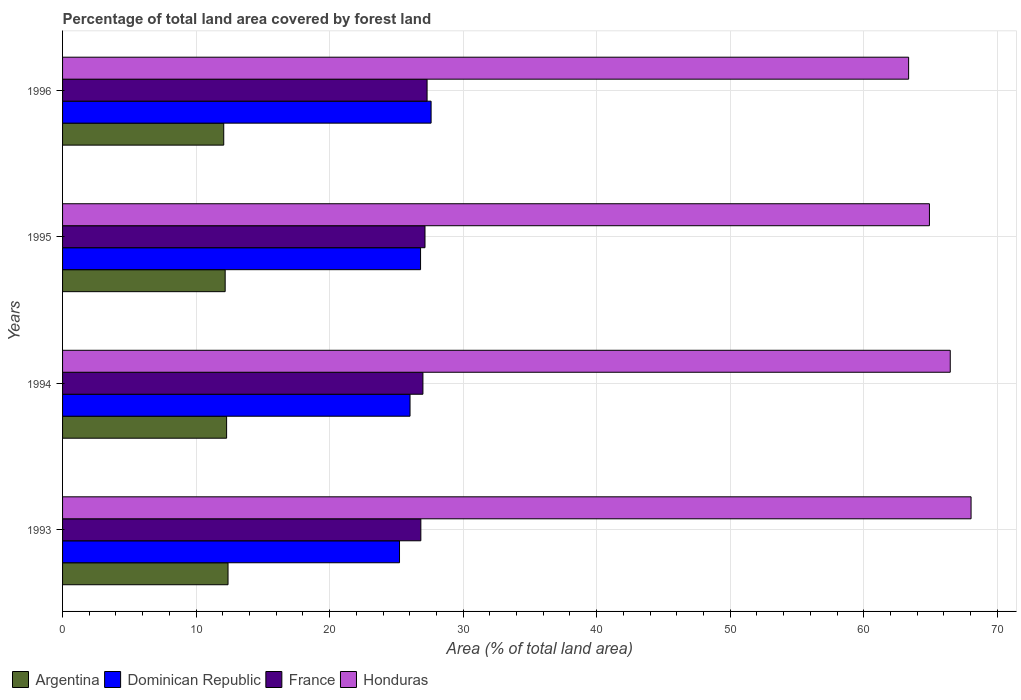How many different coloured bars are there?
Provide a succinct answer. 4. How many groups of bars are there?
Your answer should be very brief. 4. In how many cases, is the number of bars for a given year not equal to the number of legend labels?
Provide a succinct answer. 0. What is the percentage of forest land in Dominican Republic in 1994?
Offer a terse response. 26.02. Across all years, what is the maximum percentage of forest land in Dominican Republic?
Ensure brevity in your answer.  27.6. Across all years, what is the minimum percentage of forest land in Dominican Republic?
Offer a terse response. 25.23. In which year was the percentage of forest land in Honduras maximum?
Your answer should be compact. 1993. What is the total percentage of forest land in Honduras in the graph?
Provide a succinct answer. 262.8. What is the difference between the percentage of forest land in France in 1994 and that in 1996?
Offer a terse response. -0.31. What is the difference between the percentage of forest land in France in 1994 and the percentage of forest land in Honduras in 1995?
Provide a succinct answer. -37.93. What is the average percentage of forest land in Honduras per year?
Offer a terse response. 65.7. In the year 1994, what is the difference between the percentage of forest land in Dominican Republic and percentage of forest land in France?
Provide a succinct answer. -0.96. In how many years, is the percentage of forest land in Argentina greater than 10 %?
Ensure brevity in your answer.  4. What is the ratio of the percentage of forest land in Honduras in 1994 to that in 1996?
Your answer should be compact. 1.05. Is the percentage of forest land in France in 1995 less than that in 1996?
Offer a very short reply. Yes. What is the difference between the highest and the second highest percentage of forest land in Argentina?
Give a very brief answer. 0.11. What is the difference between the highest and the lowest percentage of forest land in Argentina?
Ensure brevity in your answer.  0.32. In how many years, is the percentage of forest land in Honduras greater than the average percentage of forest land in Honduras taken over all years?
Your answer should be very brief. 2. Is the sum of the percentage of forest land in Dominican Republic in 1994 and 1995 greater than the maximum percentage of forest land in France across all years?
Offer a very short reply. Yes. What does the 3rd bar from the top in 1994 represents?
Ensure brevity in your answer.  Dominican Republic. What does the 1st bar from the bottom in 1996 represents?
Make the answer very short. Argentina. How many years are there in the graph?
Ensure brevity in your answer.  4. What is the difference between two consecutive major ticks on the X-axis?
Make the answer very short. 10. Are the values on the major ticks of X-axis written in scientific E-notation?
Provide a succinct answer. No. Does the graph contain any zero values?
Give a very brief answer. No. Does the graph contain grids?
Offer a very short reply. Yes. Where does the legend appear in the graph?
Provide a succinct answer. Bottom left. How many legend labels are there?
Offer a very short reply. 4. What is the title of the graph?
Provide a succinct answer. Percentage of total land area covered by forest land. Does "Costa Rica" appear as one of the legend labels in the graph?
Offer a terse response. No. What is the label or title of the X-axis?
Give a very brief answer. Area (% of total land area). What is the Area (% of total land area) in Argentina in 1993?
Offer a very short reply. 12.39. What is the Area (% of total land area) of Dominican Republic in 1993?
Ensure brevity in your answer.  25.23. What is the Area (% of total land area) in France in 1993?
Your answer should be very brief. 26.83. What is the Area (% of total land area) in Honduras in 1993?
Provide a succinct answer. 68.04. What is the Area (% of total land area) in Argentina in 1994?
Your answer should be compact. 12.28. What is the Area (% of total land area) of Dominican Republic in 1994?
Ensure brevity in your answer.  26.02. What is the Area (% of total land area) in France in 1994?
Provide a short and direct response. 26.99. What is the Area (% of total land area) of Honduras in 1994?
Your answer should be compact. 66.48. What is the Area (% of total land area) in Argentina in 1995?
Keep it short and to the point. 12.18. What is the Area (% of total land area) of Dominican Republic in 1995?
Provide a succinct answer. 26.81. What is the Area (% of total land area) in France in 1995?
Offer a very short reply. 27.14. What is the Area (% of total land area) in Honduras in 1995?
Give a very brief answer. 64.92. What is the Area (% of total land area) in Argentina in 1996?
Provide a succinct answer. 12.07. What is the Area (% of total land area) in Dominican Republic in 1996?
Your answer should be compact. 27.6. What is the Area (% of total land area) of France in 1996?
Offer a terse response. 27.3. What is the Area (% of total land area) in Honduras in 1996?
Your answer should be compact. 63.36. Across all years, what is the maximum Area (% of total land area) in Argentina?
Provide a short and direct response. 12.39. Across all years, what is the maximum Area (% of total land area) of Dominican Republic?
Keep it short and to the point. 27.6. Across all years, what is the maximum Area (% of total land area) in France?
Ensure brevity in your answer.  27.3. Across all years, what is the maximum Area (% of total land area) in Honduras?
Your response must be concise. 68.04. Across all years, what is the minimum Area (% of total land area) of Argentina?
Offer a very short reply. 12.07. Across all years, what is the minimum Area (% of total land area) in Dominican Republic?
Your response must be concise. 25.23. Across all years, what is the minimum Area (% of total land area) of France?
Make the answer very short. 26.83. Across all years, what is the minimum Area (% of total land area) in Honduras?
Keep it short and to the point. 63.36. What is the total Area (% of total land area) of Argentina in the graph?
Provide a short and direct response. 48.92. What is the total Area (% of total land area) of Dominican Republic in the graph?
Keep it short and to the point. 105.67. What is the total Area (% of total land area) of France in the graph?
Keep it short and to the point. 108.26. What is the total Area (% of total land area) in Honduras in the graph?
Your answer should be compact. 262.8. What is the difference between the Area (% of total land area) in Argentina in 1993 and that in 1994?
Offer a terse response. 0.11. What is the difference between the Area (% of total land area) of Dominican Republic in 1993 and that in 1994?
Provide a succinct answer. -0.79. What is the difference between the Area (% of total land area) in France in 1993 and that in 1994?
Your answer should be compact. -0.16. What is the difference between the Area (% of total land area) in Honduras in 1993 and that in 1994?
Offer a very short reply. 1.56. What is the difference between the Area (% of total land area) of Argentina in 1993 and that in 1995?
Offer a terse response. 0.21. What is the difference between the Area (% of total land area) in Dominican Republic in 1993 and that in 1995?
Keep it short and to the point. -1.58. What is the difference between the Area (% of total land area) of France in 1993 and that in 1995?
Keep it short and to the point. -0.31. What is the difference between the Area (% of total land area) of Honduras in 1993 and that in 1995?
Your response must be concise. 3.12. What is the difference between the Area (% of total land area) in Argentina in 1993 and that in 1996?
Keep it short and to the point. 0.32. What is the difference between the Area (% of total land area) of Dominican Republic in 1993 and that in 1996?
Keep it short and to the point. -2.37. What is the difference between the Area (% of total land area) of France in 1993 and that in 1996?
Keep it short and to the point. -0.47. What is the difference between the Area (% of total land area) in Honduras in 1993 and that in 1996?
Provide a succinct answer. 4.68. What is the difference between the Area (% of total land area) in Argentina in 1994 and that in 1995?
Provide a succinct answer. 0.11. What is the difference between the Area (% of total land area) of Dominican Republic in 1994 and that in 1995?
Your response must be concise. -0.79. What is the difference between the Area (% of total land area) of France in 1994 and that in 1995?
Make the answer very short. -0.16. What is the difference between the Area (% of total land area) of Honduras in 1994 and that in 1995?
Your answer should be compact. 1.56. What is the difference between the Area (% of total land area) in Argentina in 1994 and that in 1996?
Your response must be concise. 0.21. What is the difference between the Area (% of total land area) in Dominican Republic in 1994 and that in 1996?
Provide a succinct answer. -1.58. What is the difference between the Area (% of total land area) in France in 1994 and that in 1996?
Provide a succinct answer. -0.31. What is the difference between the Area (% of total land area) of Honduras in 1994 and that in 1996?
Your answer should be very brief. 3.12. What is the difference between the Area (% of total land area) of Argentina in 1995 and that in 1996?
Give a very brief answer. 0.11. What is the difference between the Area (% of total land area) in Dominican Republic in 1995 and that in 1996?
Give a very brief answer. -0.79. What is the difference between the Area (% of total land area) in France in 1995 and that in 1996?
Your answer should be very brief. -0.16. What is the difference between the Area (% of total land area) of Honduras in 1995 and that in 1996?
Your answer should be very brief. 1.56. What is the difference between the Area (% of total land area) in Argentina in 1993 and the Area (% of total land area) in Dominican Republic in 1994?
Your response must be concise. -13.63. What is the difference between the Area (% of total land area) of Argentina in 1993 and the Area (% of total land area) of France in 1994?
Offer a terse response. -14.6. What is the difference between the Area (% of total land area) in Argentina in 1993 and the Area (% of total land area) in Honduras in 1994?
Offer a very short reply. -54.09. What is the difference between the Area (% of total land area) of Dominican Republic in 1993 and the Area (% of total land area) of France in 1994?
Provide a succinct answer. -1.75. What is the difference between the Area (% of total land area) of Dominican Republic in 1993 and the Area (% of total land area) of Honduras in 1994?
Your answer should be compact. -41.25. What is the difference between the Area (% of total land area) in France in 1993 and the Area (% of total land area) in Honduras in 1994?
Ensure brevity in your answer.  -39.65. What is the difference between the Area (% of total land area) of Argentina in 1993 and the Area (% of total land area) of Dominican Republic in 1995?
Your response must be concise. -14.42. What is the difference between the Area (% of total land area) of Argentina in 1993 and the Area (% of total land area) of France in 1995?
Your answer should be compact. -14.75. What is the difference between the Area (% of total land area) of Argentina in 1993 and the Area (% of total land area) of Honduras in 1995?
Offer a terse response. -52.53. What is the difference between the Area (% of total land area) of Dominican Republic in 1993 and the Area (% of total land area) of France in 1995?
Provide a short and direct response. -1.91. What is the difference between the Area (% of total land area) in Dominican Republic in 1993 and the Area (% of total land area) in Honduras in 1995?
Keep it short and to the point. -39.69. What is the difference between the Area (% of total land area) in France in 1993 and the Area (% of total land area) in Honduras in 1995?
Offer a very short reply. -38.09. What is the difference between the Area (% of total land area) of Argentina in 1993 and the Area (% of total land area) of Dominican Republic in 1996?
Offer a terse response. -15.21. What is the difference between the Area (% of total land area) of Argentina in 1993 and the Area (% of total land area) of France in 1996?
Keep it short and to the point. -14.91. What is the difference between the Area (% of total land area) of Argentina in 1993 and the Area (% of total land area) of Honduras in 1996?
Your answer should be very brief. -50.97. What is the difference between the Area (% of total land area) of Dominican Republic in 1993 and the Area (% of total land area) of France in 1996?
Ensure brevity in your answer.  -2.06. What is the difference between the Area (% of total land area) in Dominican Republic in 1993 and the Area (% of total land area) in Honduras in 1996?
Make the answer very short. -38.13. What is the difference between the Area (% of total land area) in France in 1993 and the Area (% of total land area) in Honduras in 1996?
Ensure brevity in your answer.  -36.53. What is the difference between the Area (% of total land area) of Argentina in 1994 and the Area (% of total land area) of Dominican Republic in 1995?
Your answer should be very brief. -14.53. What is the difference between the Area (% of total land area) in Argentina in 1994 and the Area (% of total land area) in France in 1995?
Provide a short and direct response. -14.86. What is the difference between the Area (% of total land area) in Argentina in 1994 and the Area (% of total land area) in Honduras in 1995?
Your response must be concise. -52.64. What is the difference between the Area (% of total land area) in Dominican Republic in 1994 and the Area (% of total land area) in France in 1995?
Your answer should be very brief. -1.12. What is the difference between the Area (% of total land area) of Dominican Republic in 1994 and the Area (% of total land area) of Honduras in 1995?
Offer a terse response. -38.9. What is the difference between the Area (% of total land area) of France in 1994 and the Area (% of total land area) of Honduras in 1995?
Offer a very short reply. -37.93. What is the difference between the Area (% of total land area) of Argentina in 1994 and the Area (% of total land area) of Dominican Republic in 1996?
Offer a very short reply. -15.31. What is the difference between the Area (% of total land area) of Argentina in 1994 and the Area (% of total land area) of France in 1996?
Make the answer very short. -15.01. What is the difference between the Area (% of total land area) of Argentina in 1994 and the Area (% of total land area) of Honduras in 1996?
Your response must be concise. -51.08. What is the difference between the Area (% of total land area) of Dominican Republic in 1994 and the Area (% of total land area) of France in 1996?
Ensure brevity in your answer.  -1.28. What is the difference between the Area (% of total land area) in Dominican Republic in 1994 and the Area (% of total land area) in Honduras in 1996?
Make the answer very short. -37.34. What is the difference between the Area (% of total land area) in France in 1994 and the Area (% of total land area) in Honduras in 1996?
Your response must be concise. -36.38. What is the difference between the Area (% of total land area) in Argentina in 1995 and the Area (% of total land area) in Dominican Republic in 1996?
Give a very brief answer. -15.42. What is the difference between the Area (% of total land area) of Argentina in 1995 and the Area (% of total land area) of France in 1996?
Make the answer very short. -15.12. What is the difference between the Area (% of total land area) in Argentina in 1995 and the Area (% of total land area) in Honduras in 1996?
Your response must be concise. -51.18. What is the difference between the Area (% of total land area) in Dominican Republic in 1995 and the Area (% of total land area) in France in 1996?
Provide a succinct answer. -0.49. What is the difference between the Area (% of total land area) in Dominican Republic in 1995 and the Area (% of total land area) in Honduras in 1996?
Your answer should be compact. -36.55. What is the difference between the Area (% of total land area) in France in 1995 and the Area (% of total land area) in Honduras in 1996?
Provide a succinct answer. -36.22. What is the average Area (% of total land area) in Argentina per year?
Offer a terse response. 12.23. What is the average Area (% of total land area) of Dominican Republic per year?
Ensure brevity in your answer.  26.42. What is the average Area (% of total land area) of France per year?
Ensure brevity in your answer.  27.07. What is the average Area (% of total land area) of Honduras per year?
Provide a short and direct response. 65.7. In the year 1993, what is the difference between the Area (% of total land area) in Argentina and Area (% of total land area) in Dominican Republic?
Make the answer very short. -12.84. In the year 1993, what is the difference between the Area (% of total land area) in Argentina and Area (% of total land area) in France?
Offer a very short reply. -14.44. In the year 1993, what is the difference between the Area (% of total land area) in Argentina and Area (% of total land area) in Honduras?
Ensure brevity in your answer.  -55.65. In the year 1993, what is the difference between the Area (% of total land area) of Dominican Republic and Area (% of total land area) of France?
Your response must be concise. -1.6. In the year 1993, what is the difference between the Area (% of total land area) of Dominican Republic and Area (% of total land area) of Honduras?
Your answer should be very brief. -42.8. In the year 1993, what is the difference between the Area (% of total land area) in France and Area (% of total land area) in Honduras?
Offer a very short reply. -41.21. In the year 1994, what is the difference between the Area (% of total land area) in Argentina and Area (% of total land area) in Dominican Republic?
Your answer should be compact. -13.74. In the year 1994, what is the difference between the Area (% of total land area) in Argentina and Area (% of total land area) in France?
Your response must be concise. -14.7. In the year 1994, what is the difference between the Area (% of total land area) in Argentina and Area (% of total land area) in Honduras?
Offer a very short reply. -54.19. In the year 1994, what is the difference between the Area (% of total land area) in Dominican Republic and Area (% of total land area) in France?
Make the answer very short. -0.96. In the year 1994, what is the difference between the Area (% of total land area) of Dominican Republic and Area (% of total land area) of Honduras?
Make the answer very short. -40.46. In the year 1994, what is the difference between the Area (% of total land area) of France and Area (% of total land area) of Honduras?
Your answer should be compact. -39.49. In the year 1995, what is the difference between the Area (% of total land area) of Argentina and Area (% of total land area) of Dominican Republic?
Offer a very short reply. -14.63. In the year 1995, what is the difference between the Area (% of total land area) in Argentina and Area (% of total land area) in France?
Your response must be concise. -14.97. In the year 1995, what is the difference between the Area (% of total land area) of Argentina and Area (% of total land area) of Honduras?
Give a very brief answer. -52.74. In the year 1995, what is the difference between the Area (% of total land area) in Dominican Republic and Area (% of total land area) in France?
Keep it short and to the point. -0.33. In the year 1995, what is the difference between the Area (% of total land area) in Dominican Republic and Area (% of total land area) in Honduras?
Your answer should be very brief. -38.11. In the year 1995, what is the difference between the Area (% of total land area) of France and Area (% of total land area) of Honduras?
Your answer should be compact. -37.78. In the year 1996, what is the difference between the Area (% of total land area) in Argentina and Area (% of total land area) in Dominican Republic?
Provide a short and direct response. -15.53. In the year 1996, what is the difference between the Area (% of total land area) in Argentina and Area (% of total land area) in France?
Your response must be concise. -15.23. In the year 1996, what is the difference between the Area (% of total land area) of Argentina and Area (% of total land area) of Honduras?
Provide a succinct answer. -51.29. In the year 1996, what is the difference between the Area (% of total land area) of Dominican Republic and Area (% of total land area) of France?
Keep it short and to the point. 0.3. In the year 1996, what is the difference between the Area (% of total land area) of Dominican Republic and Area (% of total land area) of Honduras?
Provide a succinct answer. -35.76. In the year 1996, what is the difference between the Area (% of total land area) in France and Area (% of total land area) in Honduras?
Ensure brevity in your answer.  -36.06. What is the ratio of the Area (% of total land area) of Argentina in 1993 to that in 1994?
Provide a succinct answer. 1.01. What is the ratio of the Area (% of total land area) of Dominican Republic in 1993 to that in 1994?
Ensure brevity in your answer.  0.97. What is the ratio of the Area (% of total land area) of France in 1993 to that in 1994?
Your answer should be compact. 0.99. What is the ratio of the Area (% of total land area) of Honduras in 1993 to that in 1994?
Provide a short and direct response. 1.02. What is the ratio of the Area (% of total land area) in Argentina in 1993 to that in 1995?
Make the answer very short. 1.02. What is the ratio of the Area (% of total land area) of Honduras in 1993 to that in 1995?
Ensure brevity in your answer.  1.05. What is the ratio of the Area (% of total land area) in Argentina in 1993 to that in 1996?
Make the answer very short. 1.03. What is the ratio of the Area (% of total land area) of Dominican Republic in 1993 to that in 1996?
Offer a very short reply. 0.91. What is the ratio of the Area (% of total land area) of France in 1993 to that in 1996?
Your response must be concise. 0.98. What is the ratio of the Area (% of total land area) in Honduras in 1993 to that in 1996?
Provide a succinct answer. 1.07. What is the ratio of the Area (% of total land area) of Argentina in 1994 to that in 1995?
Your answer should be compact. 1.01. What is the ratio of the Area (% of total land area) of Dominican Republic in 1994 to that in 1995?
Ensure brevity in your answer.  0.97. What is the ratio of the Area (% of total land area) of France in 1994 to that in 1995?
Keep it short and to the point. 0.99. What is the ratio of the Area (% of total land area) of Argentina in 1994 to that in 1996?
Provide a short and direct response. 1.02. What is the ratio of the Area (% of total land area) in Dominican Republic in 1994 to that in 1996?
Keep it short and to the point. 0.94. What is the ratio of the Area (% of total land area) in France in 1994 to that in 1996?
Your response must be concise. 0.99. What is the ratio of the Area (% of total land area) in Honduras in 1994 to that in 1996?
Your response must be concise. 1.05. What is the ratio of the Area (% of total land area) of Argentina in 1995 to that in 1996?
Provide a short and direct response. 1.01. What is the ratio of the Area (% of total land area) of Dominican Republic in 1995 to that in 1996?
Your answer should be compact. 0.97. What is the ratio of the Area (% of total land area) of France in 1995 to that in 1996?
Your answer should be compact. 0.99. What is the ratio of the Area (% of total land area) in Honduras in 1995 to that in 1996?
Provide a short and direct response. 1.02. What is the difference between the highest and the second highest Area (% of total land area) in Argentina?
Make the answer very short. 0.11. What is the difference between the highest and the second highest Area (% of total land area) of Dominican Republic?
Offer a terse response. 0.79. What is the difference between the highest and the second highest Area (% of total land area) of France?
Provide a short and direct response. 0.16. What is the difference between the highest and the second highest Area (% of total land area) in Honduras?
Make the answer very short. 1.56. What is the difference between the highest and the lowest Area (% of total land area) in Argentina?
Your response must be concise. 0.32. What is the difference between the highest and the lowest Area (% of total land area) in Dominican Republic?
Your response must be concise. 2.37. What is the difference between the highest and the lowest Area (% of total land area) in France?
Keep it short and to the point. 0.47. What is the difference between the highest and the lowest Area (% of total land area) of Honduras?
Your response must be concise. 4.68. 